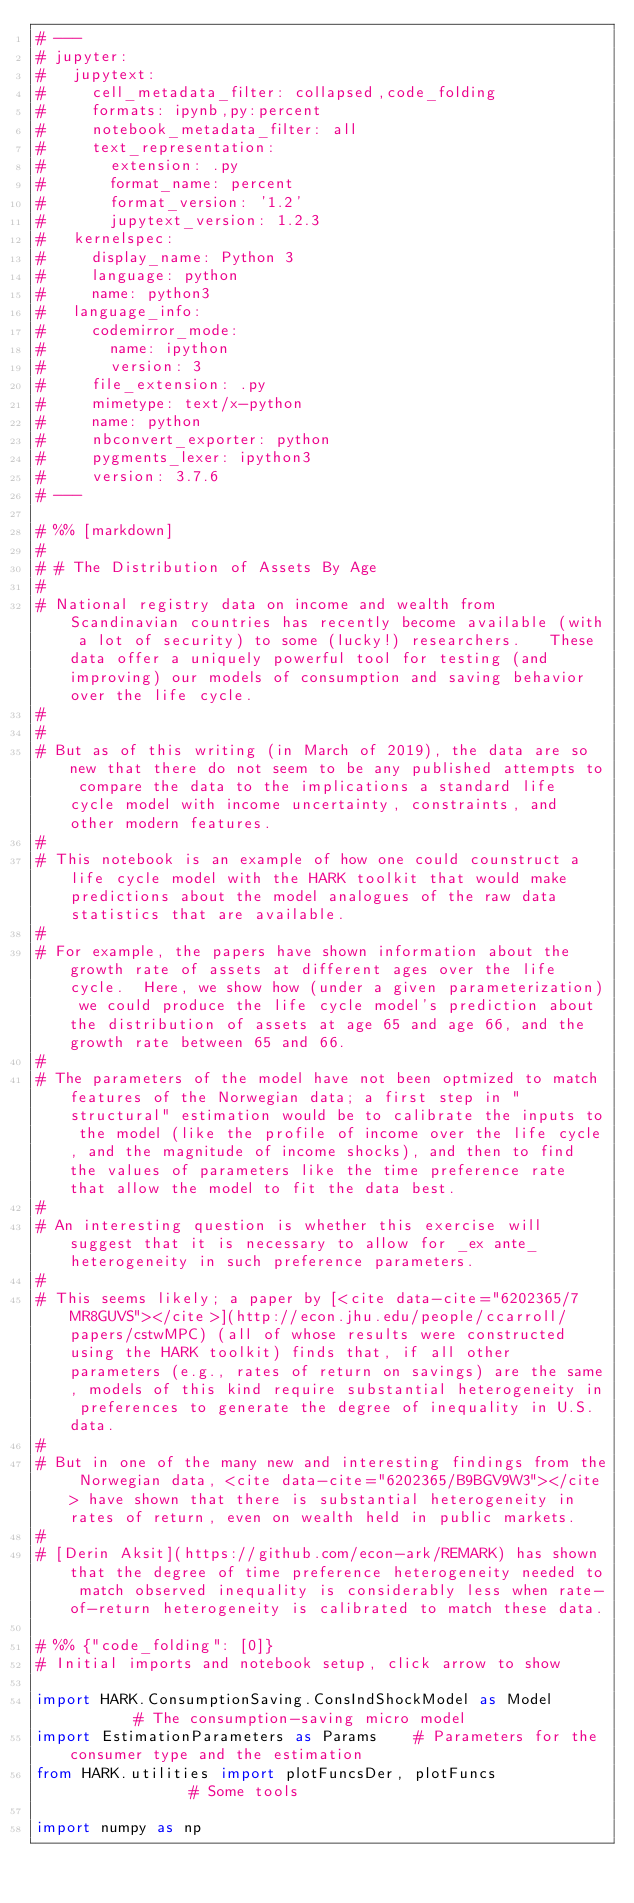<code> <loc_0><loc_0><loc_500><loc_500><_Python_># ---
# jupyter:
#   jupytext:
#     cell_metadata_filter: collapsed,code_folding
#     formats: ipynb,py:percent
#     notebook_metadata_filter: all
#     text_representation:
#       extension: .py
#       format_name: percent
#       format_version: '1.2'
#       jupytext_version: 1.2.3
#   kernelspec:
#     display_name: Python 3
#     language: python
#     name: python3
#   language_info:
#     codemirror_mode:
#       name: ipython
#       version: 3
#     file_extension: .py
#     mimetype: text/x-python
#     name: python
#     nbconvert_exporter: python
#     pygments_lexer: ipython3
#     version: 3.7.6
# ---

# %% [markdown]
#
# # The Distribution of Assets By Age
#
# National registry data on income and wealth from Scandinavian countries has recently become available (with a lot of security) to some (lucky!) researchers.   These data offer a uniquely powerful tool for testing (and improving) our models of consumption and saving behavior over the life cycle.
#
#
# But as of this writing (in March of 2019), the data are so new that there do not seem to be any published attempts to compare the data to the implications a standard life cycle model with income uncertainty, constraints, and other modern features.
#
# This notebook is an example of how one could counstruct a life cycle model with the HARK toolkit that would make predictions about the model analogues of the raw data statistics that are available.  
#
# For example, the papers have shown information about the growth rate of assets at different ages over the life cycle.  Here, we show how (under a given parameterization) we could produce the life cycle model's prediction about the distribution of assets at age 65 and age 66, and the growth rate between 65 and 66. 
#
# The parameters of the model have not been optmized to match features of the Norwegian data; a first step in "structural" estimation would be to calibrate the inputs to the model (like the profile of income over the life cycle, and the magnitude of income shocks), and then to find the values of parameters like the time preference rate that allow the model to fit the data best.
#
# An interesting question is whether this exercise will suggest that it is necessary to allow for _ex ante_ heterogeneity in such preference parameters.
#
# This seems likely; a paper by [<cite data-cite="6202365/7MR8GUVS"></cite>](http://econ.jhu.edu/people/ccarroll/papers/cstwMPC) (all of whose results were constructed using the HARK toolkit) finds that, if all other parameters (e.g., rates of return on savings) are the same, models of this kind require substantial heterogeneity in preferences to generate the degree of inequality in U.S. data.
#
# But in one of the many new and interesting findings from the Norwegian data, <cite data-cite="6202365/B9BGV9W3"></cite> have shown that there is substantial heterogeneity in rates of return, even on wealth held in public markets.  
#
# [Derin Aksit](https://github.com/econ-ark/REMARK) has shown that the degree of time preference heterogeneity needed to match observed inequality is considerably less when rate-of-return heterogeneity is calibrated to match these data.

# %% {"code_folding": [0]}
# Initial imports and notebook setup, click arrow to show

import HARK.ConsumptionSaving.ConsIndShockModel as Model        # The consumption-saving micro model
import EstimationParameters as Params    # Parameters for the consumer type and the estimation
from HARK.utilities import plotFuncsDer, plotFuncs              # Some tools

import numpy as np

</code> 